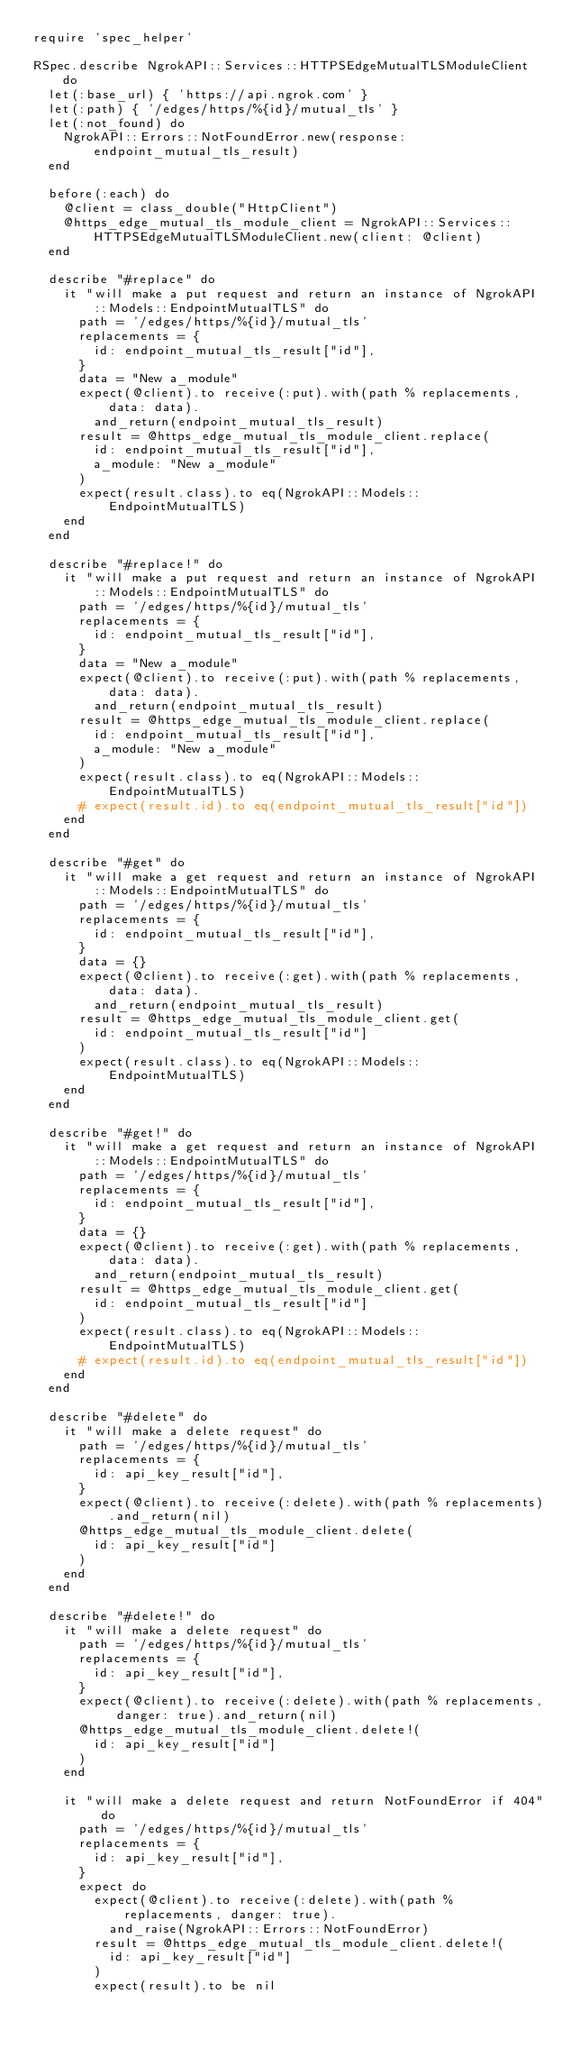Convert code to text. <code><loc_0><loc_0><loc_500><loc_500><_Ruby_>require 'spec_helper'

RSpec.describe NgrokAPI::Services::HTTPSEdgeMutualTLSModuleClient do
  let(:base_url) { 'https://api.ngrok.com' }
  let(:path) { '/edges/https/%{id}/mutual_tls' }
  let(:not_found) do
    NgrokAPI::Errors::NotFoundError.new(response: endpoint_mutual_tls_result)
  end

  before(:each) do
    @client = class_double("HttpClient")
    @https_edge_mutual_tls_module_client = NgrokAPI::Services::HTTPSEdgeMutualTLSModuleClient.new(client: @client)
  end

  describe "#replace" do
    it "will make a put request and return an instance of NgrokAPI::Models::EndpointMutualTLS" do
      path = '/edges/https/%{id}/mutual_tls'
      replacements = {
        id: endpoint_mutual_tls_result["id"],
      }
      data = "New a_module"
      expect(@client).to receive(:put).with(path % replacements, data: data).
        and_return(endpoint_mutual_tls_result)
      result = @https_edge_mutual_tls_module_client.replace(
        id: endpoint_mutual_tls_result["id"],
        a_module: "New a_module"
      )
      expect(result.class).to eq(NgrokAPI::Models::EndpointMutualTLS)
    end
  end

  describe "#replace!" do
    it "will make a put request and return an instance of NgrokAPI::Models::EndpointMutualTLS" do
      path = '/edges/https/%{id}/mutual_tls'
      replacements = {
        id: endpoint_mutual_tls_result["id"],
      }
      data = "New a_module"
      expect(@client).to receive(:put).with(path % replacements, data: data).
        and_return(endpoint_mutual_tls_result)
      result = @https_edge_mutual_tls_module_client.replace(
        id: endpoint_mutual_tls_result["id"],
        a_module: "New a_module"
      )
      expect(result.class).to eq(NgrokAPI::Models::EndpointMutualTLS)
      # expect(result.id).to eq(endpoint_mutual_tls_result["id"])
    end
  end

  describe "#get" do
    it "will make a get request and return an instance of NgrokAPI::Models::EndpointMutualTLS" do
      path = '/edges/https/%{id}/mutual_tls'
      replacements = {
        id: endpoint_mutual_tls_result["id"],
      }
      data = {}
      expect(@client).to receive(:get).with(path % replacements, data: data).
        and_return(endpoint_mutual_tls_result)
      result = @https_edge_mutual_tls_module_client.get(
        id: endpoint_mutual_tls_result["id"]
      )
      expect(result.class).to eq(NgrokAPI::Models::EndpointMutualTLS)
    end
  end

  describe "#get!" do
    it "will make a get request and return an instance of NgrokAPI::Models::EndpointMutualTLS" do
      path = '/edges/https/%{id}/mutual_tls'
      replacements = {
        id: endpoint_mutual_tls_result["id"],
      }
      data = {}
      expect(@client).to receive(:get).with(path % replacements, data: data).
        and_return(endpoint_mutual_tls_result)
      result = @https_edge_mutual_tls_module_client.get(
        id: endpoint_mutual_tls_result["id"]
      )
      expect(result.class).to eq(NgrokAPI::Models::EndpointMutualTLS)
      # expect(result.id).to eq(endpoint_mutual_tls_result["id"])
    end
  end

  describe "#delete" do
    it "will make a delete request" do
      path = '/edges/https/%{id}/mutual_tls'
      replacements = {
        id: api_key_result["id"],
      }
      expect(@client).to receive(:delete).with(path % replacements).and_return(nil)
      @https_edge_mutual_tls_module_client.delete(
        id: api_key_result["id"]
      )
    end
  end

  describe "#delete!" do
    it "will make a delete request" do
      path = '/edges/https/%{id}/mutual_tls'
      replacements = {
        id: api_key_result["id"],
      }
      expect(@client).to receive(:delete).with(path % replacements, danger: true).and_return(nil)
      @https_edge_mutual_tls_module_client.delete!(
        id: api_key_result["id"]
      )
    end

    it "will make a delete request and return NotFoundError if 404" do
      path = '/edges/https/%{id}/mutual_tls'
      replacements = {
        id: api_key_result["id"],
      }
      expect do
        expect(@client).to receive(:delete).with(path % replacements, danger: true).
          and_raise(NgrokAPI::Errors::NotFoundError)
        result = @https_edge_mutual_tls_module_client.delete!(
          id: api_key_result["id"]
        )
        expect(result).to be nil</code> 